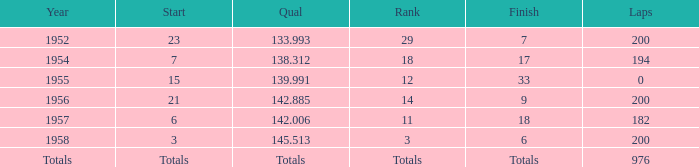Would you be able to parse every entry in this table? {'header': ['Year', 'Start', 'Qual', 'Rank', 'Finish', 'Laps'], 'rows': [['1952', '23', '133.993', '29', '7', '200'], ['1954', '7', '138.312', '18', '17', '194'], ['1955', '15', '139.991', '12', '33', '0'], ['1956', '21', '142.885', '14', '9', '200'], ['1957', '6', '142.006', '11', '18', '182'], ['1958', '3', '145.513', '3', '6', '200'], ['Totals', 'Totals', 'Totals', 'Totals', 'Totals', '976']]} From which position did jimmy reece begin when he achieved a ranking of 12? 15.0. 